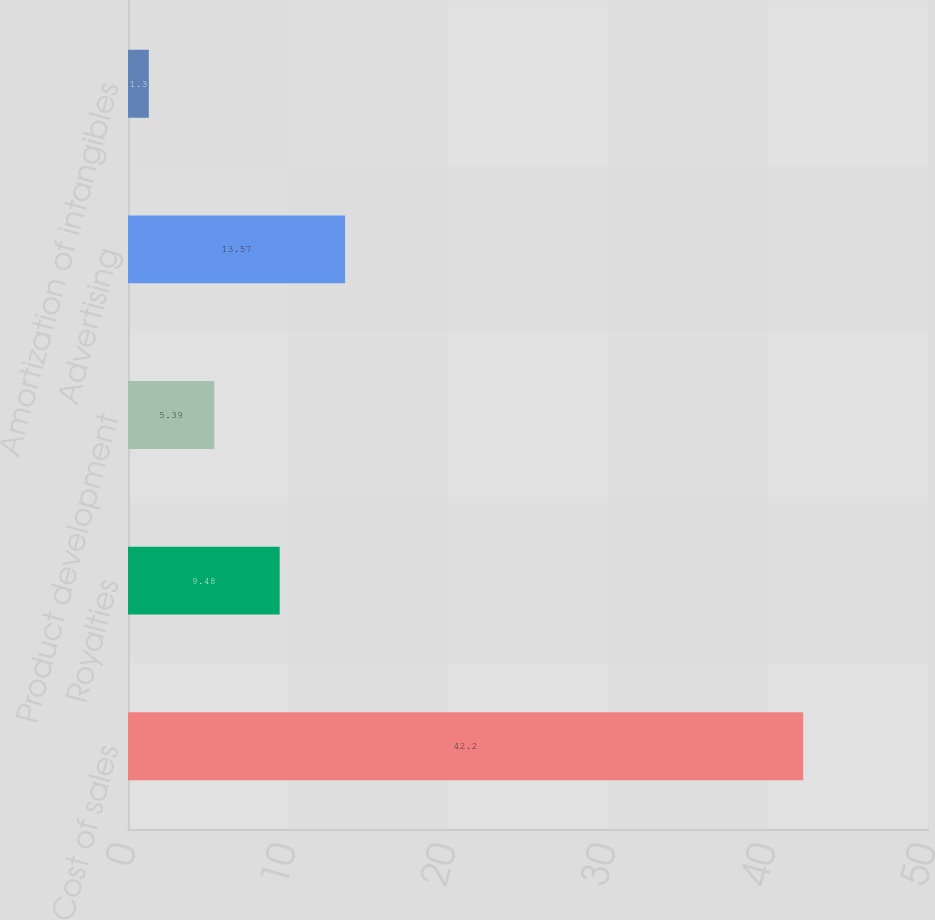Convert chart to OTSL. <chart><loc_0><loc_0><loc_500><loc_500><bar_chart><fcel>Cost of sales<fcel>Royalties<fcel>Product development<fcel>Advertising<fcel>Amortization of intangibles<nl><fcel>42.2<fcel>9.48<fcel>5.39<fcel>13.57<fcel>1.3<nl></chart> 